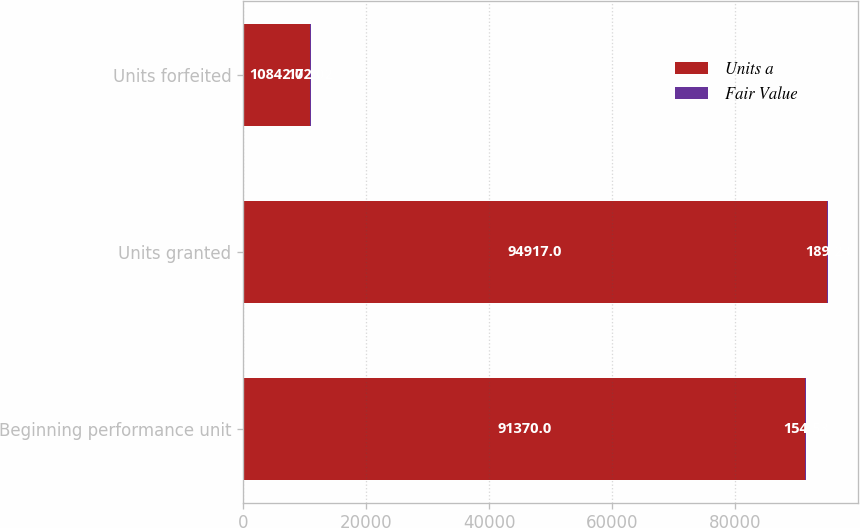<chart> <loc_0><loc_0><loc_500><loc_500><stacked_bar_chart><ecel><fcel>Beginning performance unit<fcel>Units granted<fcel>Units forfeited<nl><fcel>Units a<fcel>91370<fcel>94917<fcel>10842<nl><fcel>Fair Value<fcel>154.53<fcel>189.23<fcel>172.02<nl></chart> 